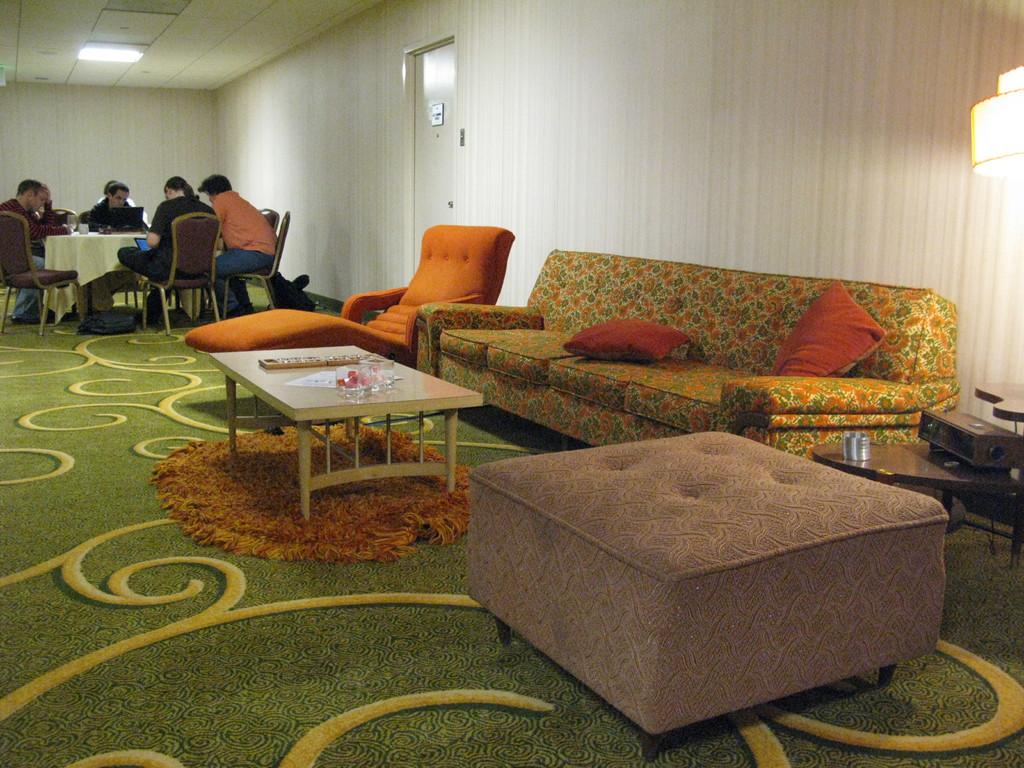What type of furniture is present in the image? There is a table, a couch, and chairs in the image. What type of flooring is visible in the image? There is a carpet in the image. What type of accessory is present in the image? There is a lamp in the image. What type of window treatment is present in the image? There is a curtain in the image. What type of architectural feature is present in the image? There is a door in the image. What is the group of people doing in the image? The group of people is sitting in chairs in the image. What type of pin is holding the pear to the swing in the image? There is no pin, pear, or swing present in the image. 